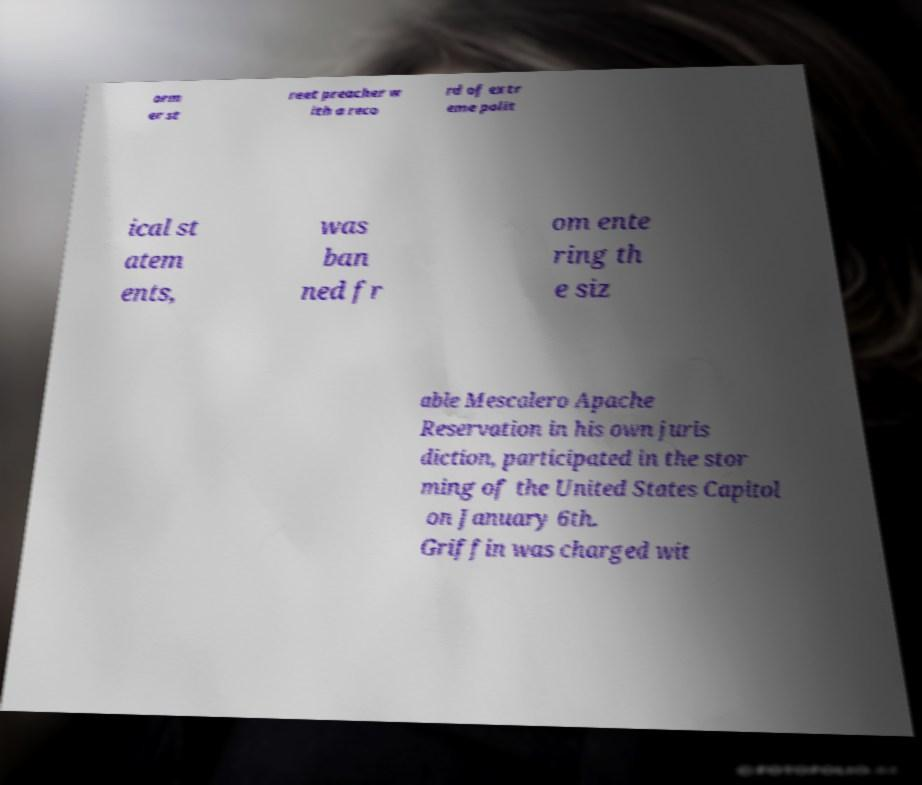Could you extract and type out the text from this image? orm er st reet preacher w ith a reco rd of extr eme polit ical st atem ents, was ban ned fr om ente ring th e siz able Mescalero Apache Reservation in his own juris diction, participated in the stor ming of the United States Capitol on January 6th. Griffin was charged wit 